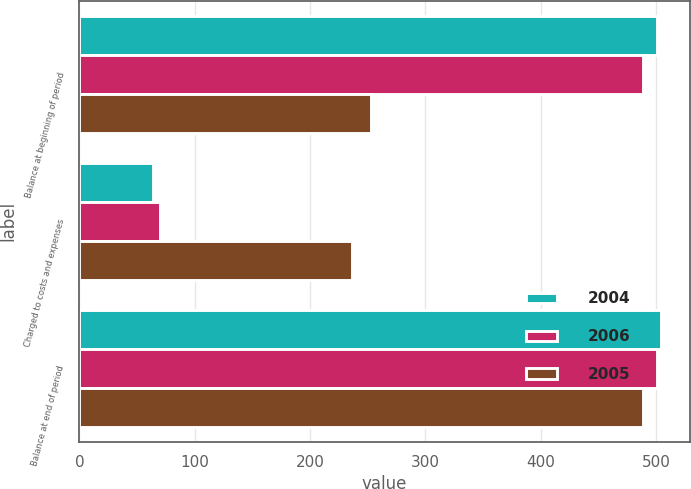Convert chart to OTSL. <chart><loc_0><loc_0><loc_500><loc_500><stacked_bar_chart><ecel><fcel>Balance at beginning of period<fcel>Charged to costs and expenses<fcel>Balance at end of period<nl><fcel>2004<fcel>501<fcel>63.6<fcel>504<nl><fcel>2006<fcel>488.6<fcel>69.9<fcel>501<nl><fcel>2005<fcel>252.6<fcel>236<fcel>488.6<nl></chart> 